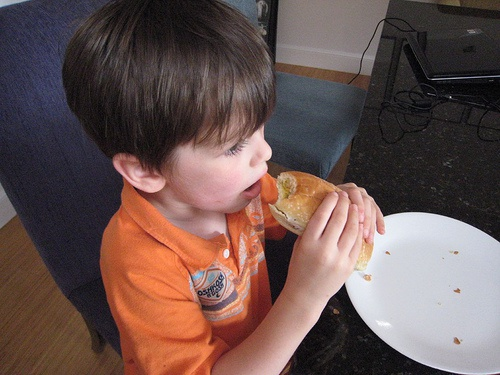Describe the objects in this image and their specific colors. I can see people in darkgray, black, brown, lightpink, and maroon tones, dining table in darkgray, black, and lightgray tones, chair in darkgray, black, purple, and navy tones, chair in darkgray, gray, and black tones, and laptop in darkgray, black, and gray tones in this image. 